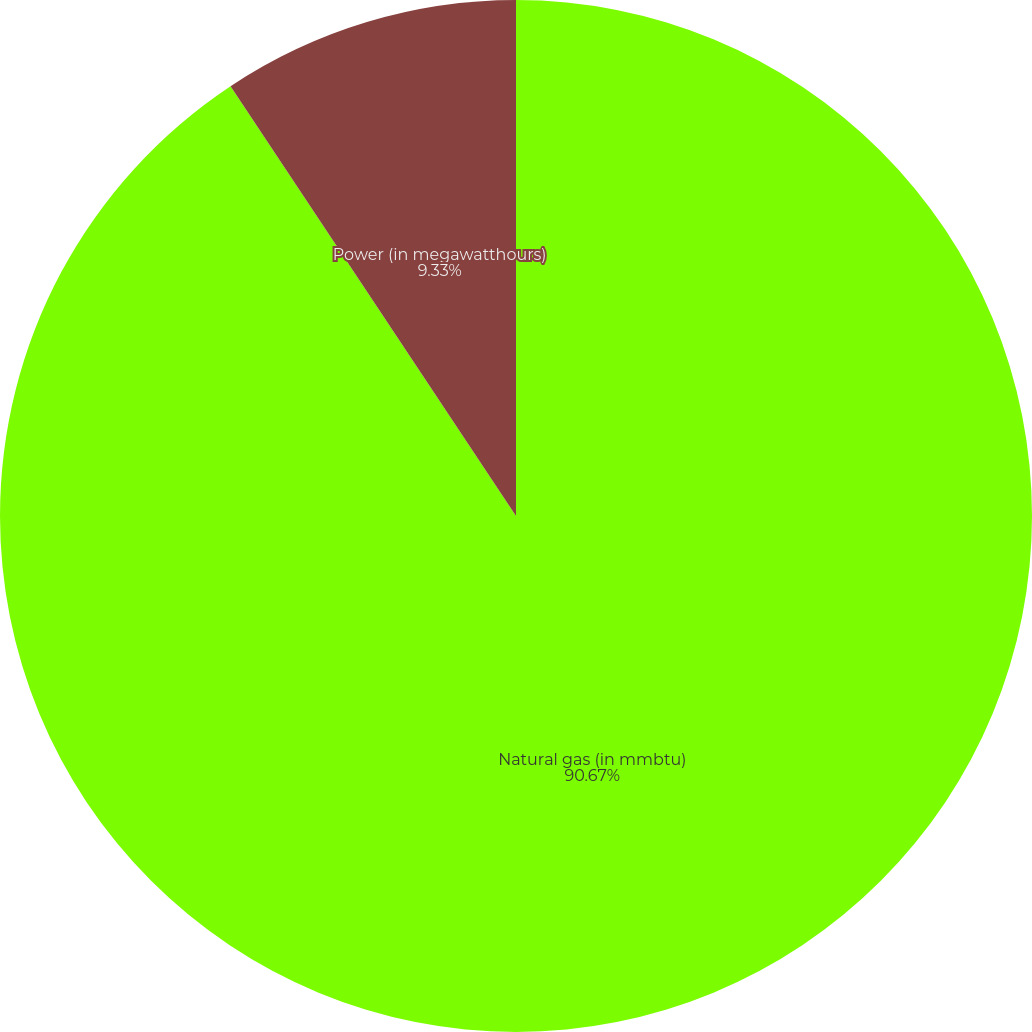Convert chart. <chart><loc_0><loc_0><loc_500><loc_500><pie_chart><fcel>Natural gas (in mmbtu)<fcel>Power (in megawatthours)<nl><fcel>90.67%<fcel>9.33%<nl></chart> 